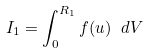Convert formula to latex. <formula><loc_0><loc_0><loc_500><loc_500>I _ { 1 } = \int _ { 0 } ^ { R _ { 1 } } f ( u ) \ d V</formula> 